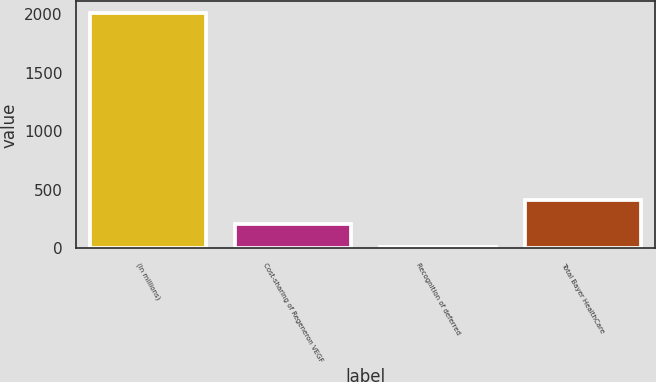<chart> <loc_0><loc_0><loc_500><loc_500><bar_chart><fcel>(In millions)<fcel>Cost-sharing of Regeneron VEGF<fcel>Recognition of deferred<fcel>Total Bayer HealthCare<nl><fcel>2009<fcel>209.81<fcel>9.9<fcel>409.72<nl></chart> 